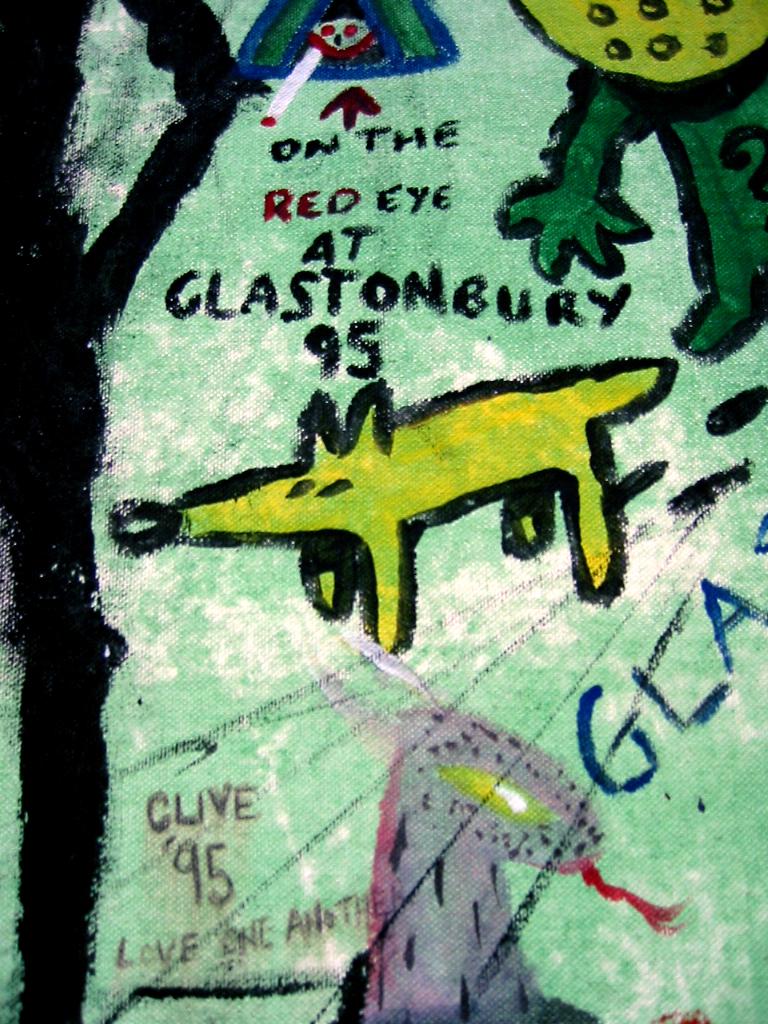What animal is the main focus?
Ensure brevity in your answer.  Answering does not require reading text in the image. What year is printed on this?
Provide a short and direct response. 95. 